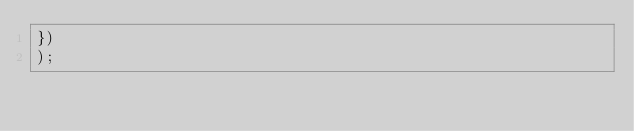<code> <loc_0><loc_0><loc_500><loc_500><_JavaScript_>})
);
</code> 